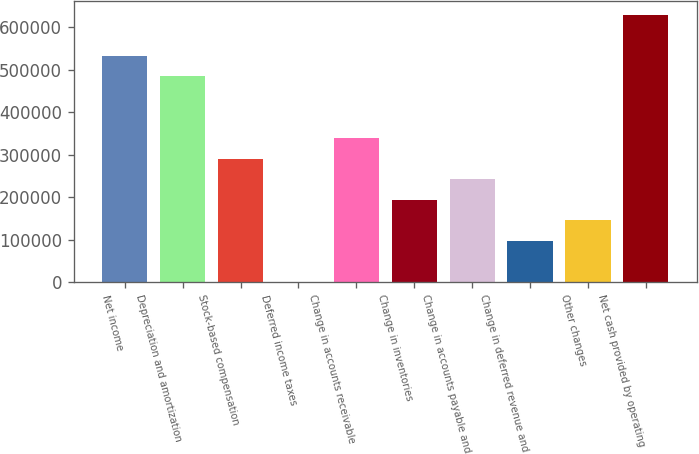<chart> <loc_0><loc_0><loc_500><loc_500><bar_chart><fcel>Net income<fcel>Depreciation and amortization<fcel>Stock-based compensation<fcel>Deferred income taxes<fcel>Change in accounts receivable<fcel>Change in inventories<fcel>Change in accounts payable and<fcel>Change in deferred revenue and<fcel>Other changes<fcel>Net cash provided by operating<nl><fcel>533347<fcel>484876<fcel>290993<fcel>169<fcel>339464<fcel>194052<fcel>242522<fcel>97110.4<fcel>145581<fcel>630288<nl></chart> 